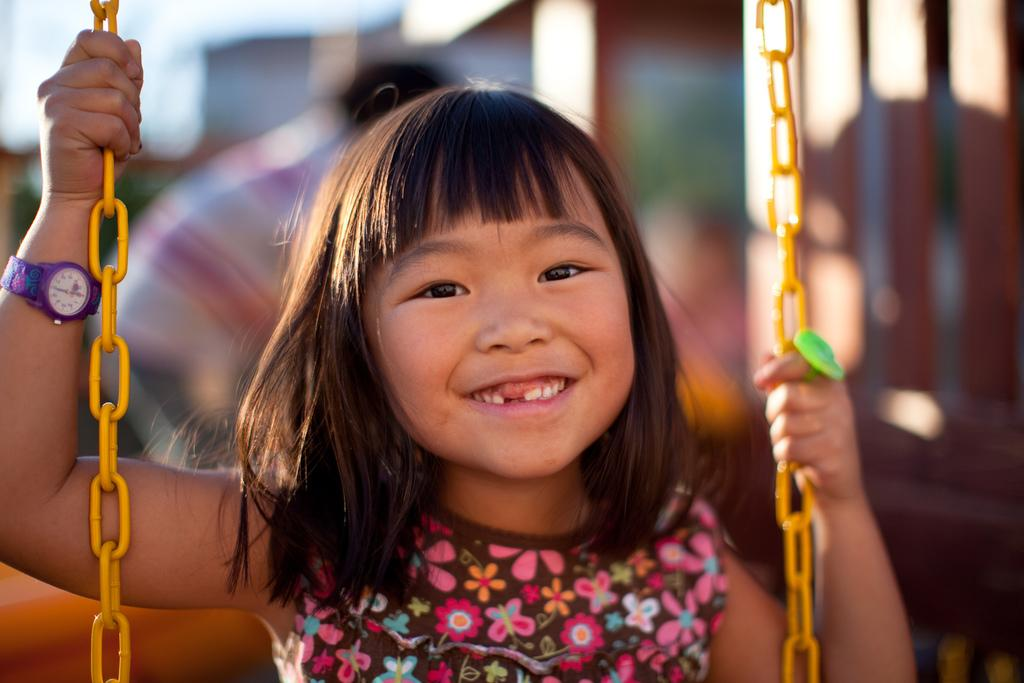What is the main subject of the image? The main subject of the image is a kid. What is the kid wearing? The kid is wearing clothes. What is the kid holding in her hands? The kid is holding chains in her hands. Can you describe the background of the image? The background of the image is blurred. What type of crown is the kid wearing in the image? There is no crown present in the image; the kid is wearing clothes. What are the kid's hobbies, as depicted in the image? The image does not provide information about the kid's hobbies. --- Facts: 1. There is a car in the image. 2. The car is red. 3. The car has four wheels. 4. There are people in the car. 5. The car is parked on the street. Absurd Topics: parrot, ocean, volcano Conversation: What is the main subject of the image? The main subject of the image is a car. What color is the car? The car is red. How many wheels does the car have? The car has four wheels. Are there any passengers in the car? Yes, there are people in the car. Where is the car located in the image? The car is parked on the street. Reasoning: Let's think step by step in order to produce the conversation. We start by identifying the main subject of the image, which is the car. Then, we describe the car's appearance, including its color and the number of wheels. Next, we mention the presence of passengers in the car. Finally, we describe the car's location, noting that it is parked on the street. Absurd Question/Answer: Can you see a parrot flying over the car in the image? There is no parrot present in the image. Is the car parked near an ocean or volcano in the image? The image does not show any ocean or volcano; it only shows a car parked on the street. 